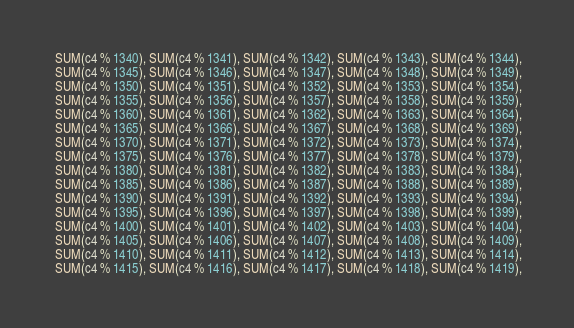<code> <loc_0><loc_0><loc_500><loc_500><_SQL_> SUM(c4 % 1340), SUM(c4 % 1341), SUM(c4 % 1342), SUM(c4 % 1343), SUM(c4 % 1344),
 SUM(c4 % 1345), SUM(c4 % 1346), SUM(c4 % 1347), SUM(c4 % 1348), SUM(c4 % 1349),
 SUM(c4 % 1350), SUM(c4 % 1351), SUM(c4 % 1352), SUM(c4 % 1353), SUM(c4 % 1354),
 SUM(c4 % 1355), SUM(c4 % 1356), SUM(c4 % 1357), SUM(c4 % 1358), SUM(c4 % 1359),
 SUM(c4 % 1360), SUM(c4 % 1361), SUM(c4 % 1362), SUM(c4 % 1363), SUM(c4 % 1364),
 SUM(c4 % 1365), SUM(c4 % 1366), SUM(c4 % 1367), SUM(c4 % 1368), SUM(c4 % 1369),
 SUM(c4 % 1370), SUM(c4 % 1371), SUM(c4 % 1372), SUM(c4 % 1373), SUM(c4 % 1374),
 SUM(c4 % 1375), SUM(c4 % 1376), SUM(c4 % 1377), SUM(c4 % 1378), SUM(c4 % 1379),
 SUM(c4 % 1380), SUM(c4 % 1381), SUM(c4 % 1382), SUM(c4 % 1383), SUM(c4 % 1384),
 SUM(c4 % 1385), SUM(c4 % 1386), SUM(c4 % 1387), SUM(c4 % 1388), SUM(c4 % 1389),
 SUM(c4 % 1390), SUM(c4 % 1391), SUM(c4 % 1392), SUM(c4 % 1393), SUM(c4 % 1394),
 SUM(c4 % 1395), SUM(c4 % 1396), SUM(c4 % 1397), SUM(c4 % 1398), SUM(c4 % 1399),
 SUM(c4 % 1400), SUM(c4 % 1401), SUM(c4 % 1402), SUM(c4 % 1403), SUM(c4 % 1404),
 SUM(c4 % 1405), SUM(c4 % 1406), SUM(c4 % 1407), SUM(c4 % 1408), SUM(c4 % 1409),
 SUM(c4 % 1410), SUM(c4 % 1411), SUM(c4 % 1412), SUM(c4 % 1413), SUM(c4 % 1414),
 SUM(c4 % 1415), SUM(c4 % 1416), SUM(c4 % 1417), SUM(c4 % 1418), SUM(c4 % 1419),</code> 